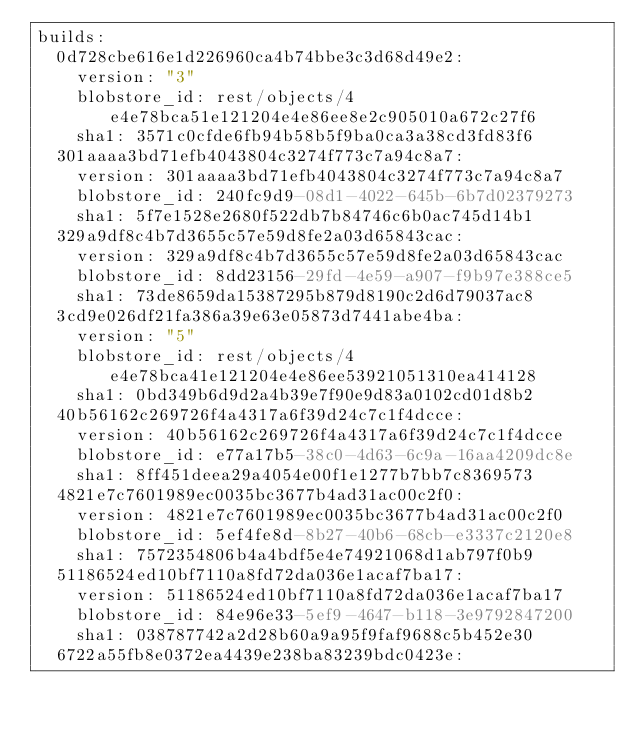Convert code to text. <code><loc_0><loc_0><loc_500><loc_500><_YAML_>builds:
  0d728cbe616e1d226960ca4b74bbe3c3d68d49e2:
    version: "3"
    blobstore_id: rest/objects/4e4e78bca51e121204e4e86ee8e2c905010a672c27f6
    sha1: 3571c0cfde6fb94b58b5f9ba0ca3a38cd3fd83f6
  301aaaa3bd71efb4043804c3274f773c7a94c8a7:
    version: 301aaaa3bd71efb4043804c3274f773c7a94c8a7
    blobstore_id: 240fc9d9-08d1-4022-645b-6b7d02379273
    sha1: 5f7e1528e2680f522db7b84746c6b0ac745d14b1
  329a9df8c4b7d3655c57e59d8fe2a03d65843cac:
    version: 329a9df8c4b7d3655c57e59d8fe2a03d65843cac
    blobstore_id: 8dd23156-29fd-4e59-a907-f9b97e388ce5
    sha1: 73de8659da15387295b879d8190c2d6d79037ac8
  3cd9e026df21fa386a39e63e05873d7441abe4ba:
    version: "5"
    blobstore_id: rest/objects/4e4e78bca41e121204e4e86ee53921051310ea414128
    sha1: 0bd349b6d9d2a4b39e7f90e9d83a0102cd01d8b2
  40b56162c269726f4a4317a6f39d24c7c1f4dcce:
    version: 40b56162c269726f4a4317a6f39d24c7c1f4dcce
    blobstore_id: e77a17b5-38c0-4d63-6c9a-16aa4209dc8e
    sha1: 8ff451deea29a4054e00f1e1277b7bb7c8369573
  4821e7c7601989ec0035bc3677b4ad31ac00c2f0:
    version: 4821e7c7601989ec0035bc3677b4ad31ac00c2f0
    blobstore_id: 5ef4fe8d-8b27-40b6-68cb-e3337c2120e8
    sha1: 7572354806b4a4bdf5e4e74921068d1ab797f0b9
  51186524ed10bf7110a8fd72da036e1acaf7ba17:
    version: 51186524ed10bf7110a8fd72da036e1acaf7ba17
    blobstore_id: 84e96e33-5ef9-4647-b118-3e9792847200
    sha1: 038787742a2d28b60a9a95f9faf9688c5b452e30
  6722a55fb8e0372ea4439e238ba83239bdc0423e:</code> 